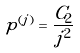Convert formula to latex. <formula><loc_0><loc_0><loc_500><loc_500>p ^ { ( j ) } = \frac { C _ { 2 } } { j ^ { 2 } }</formula> 